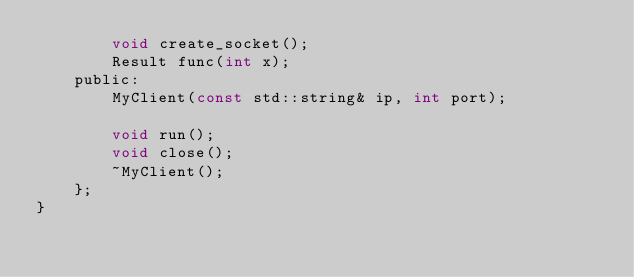<code> <loc_0><loc_0><loc_500><loc_500><_C_>        void create_socket();
        Result func(int x);
    public:
        MyClient(const std::string& ip, int port);

        void run();
        void close();
        ~MyClient();
	};
}


</code> 